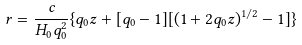<formula> <loc_0><loc_0><loc_500><loc_500>r = \frac { c } { H _ { 0 } q _ { 0 } ^ { 2 } } \{ q _ { 0 } z + [ q _ { 0 } - 1 ] [ ( 1 + 2 q _ { 0 } z ) ^ { 1 / 2 } - 1 ] \}</formula> 